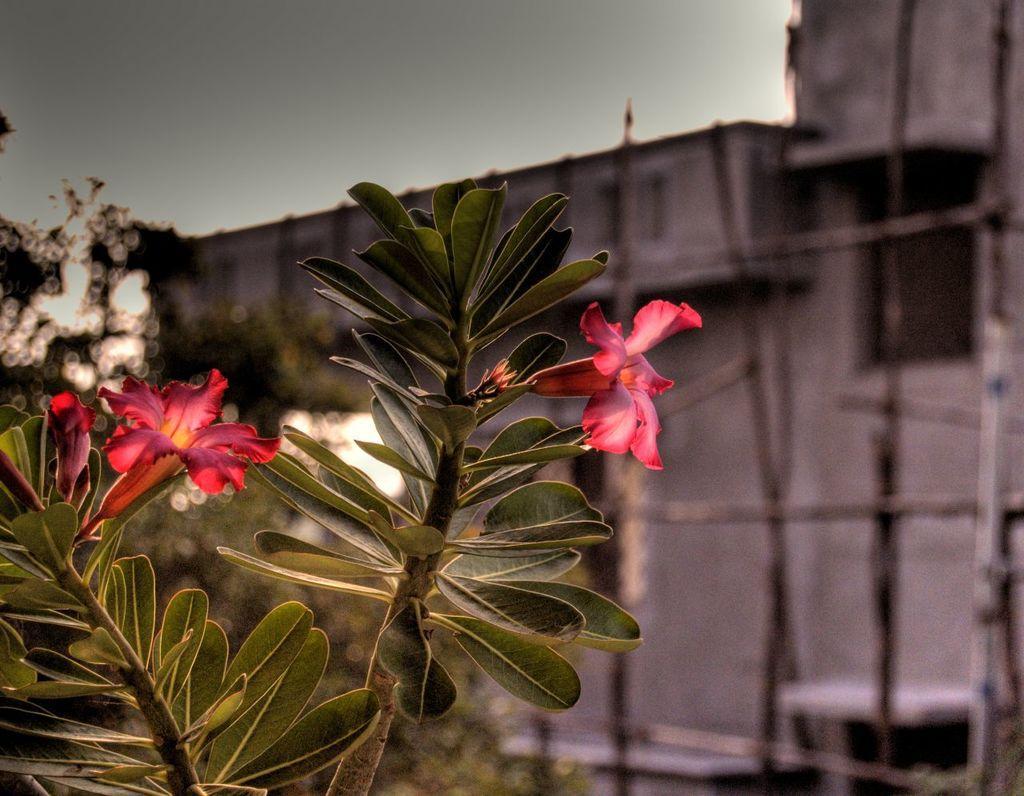Describe this image in one or two sentences. On the left side of the image we can see one plant and flowers, which are in pink color. In the background we can see the sky, one building, trees and a few other objects. 